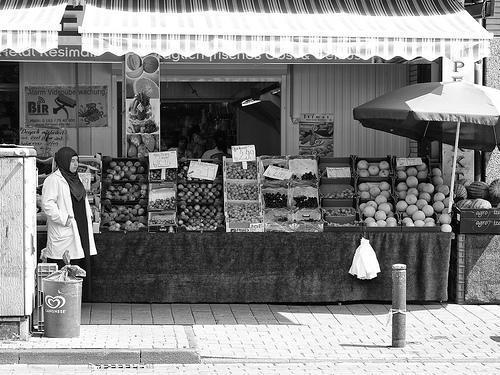How many people can be seen in front of the store?
Give a very brief answer. 1. 